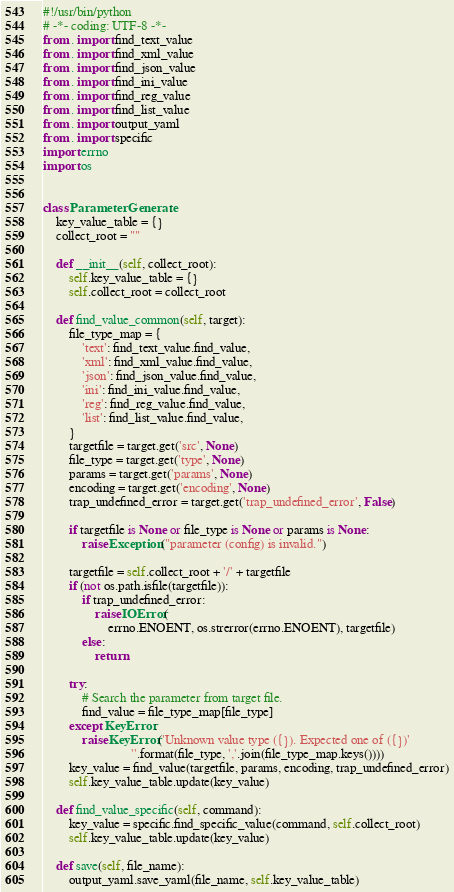<code> <loc_0><loc_0><loc_500><loc_500><_Python_>#!/usr/bin/python
# -*- coding: UTF-8 -*-
from . import find_text_value
from . import find_xml_value
from . import find_json_value
from . import find_ini_value
from . import find_reg_value
from . import find_list_value
from . import output_yaml
from . import specific
import errno
import os


class ParameterGenerate:
    key_value_table = {}
    collect_root = ""

    def __init__(self, collect_root):
        self.key_value_table = {}
        self.collect_root = collect_root

    def find_value_common(self, target):
        file_type_map = {
            'text': find_text_value.find_value,
            'xml': find_xml_value.find_value,
            'json': find_json_value.find_value,
            'ini': find_ini_value.find_value,
            'reg': find_reg_value.find_value,
            'list': find_list_value.find_value,
        }
        targetfile = target.get('src', None)
        file_type = target.get('type', None)
        params = target.get('params', None)
        encoding = target.get('encoding', None)
        trap_undefined_error = target.get('trap_undefined_error', False)

        if targetfile is None or file_type is None or params is None:
            raise Exception("parameter (config) is invalid.")

        targetfile = self.collect_root + '/' + targetfile
        if (not os.path.isfile(targetfile)):
            if trap_undefined_error:
                raise IOError(
                    errno.ENOENT, os.strerror(errno.ENOENT), targetfile)
            else:
                return

        try:
            # Search the parameter from target file.
            find_value = file_type_map[file_type]
        except KeyError:
            raise KeyError('Unknown value type ({}). Expected one of ({})'
                           ''.format(file_type, ','.join(file_type_map.keys())))
        key_value = find_value(targetfile, params, encoding, trap_undefined_error)
        self.key_value_table.update(key_value)

    def find_value_specific(self, command):
        key_value = specific.find_specific_value(command, self.collect_root)
        self.key_value_table.update(key_value)

    def save(self, file_name):
        output_yaml.save_yaml(file_name, self.key_value_table)
</code> 